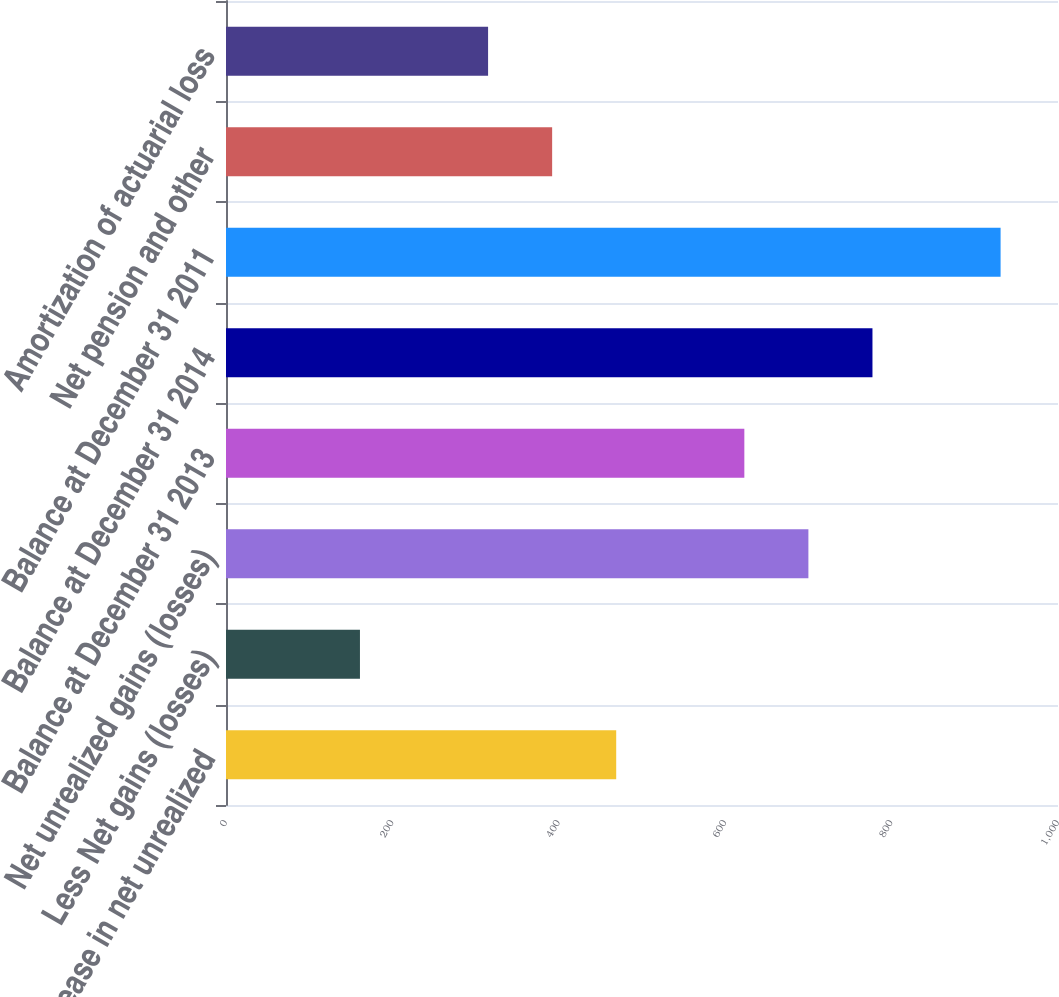Convert chart to OTSL. <chart><loc_0><loc_0><loc_500><loc_500><bar_chart><fcel>Increase in net unrealized<fcel>Less Net gains (losses)<fcel>Net unrealized gains (losses)<fcel>Balance at December 31 2013<fcel>Balance at December 31 2014<fcel>Balance at December 31 2011<fcel>Net pension and other<fcel>Amortization of actuarial loss<nl><fcel>469<fcel>161<fcel>700<fcel>623<fcel>777<fcel>931<fcel>392<fcel>315<nl></chart> 